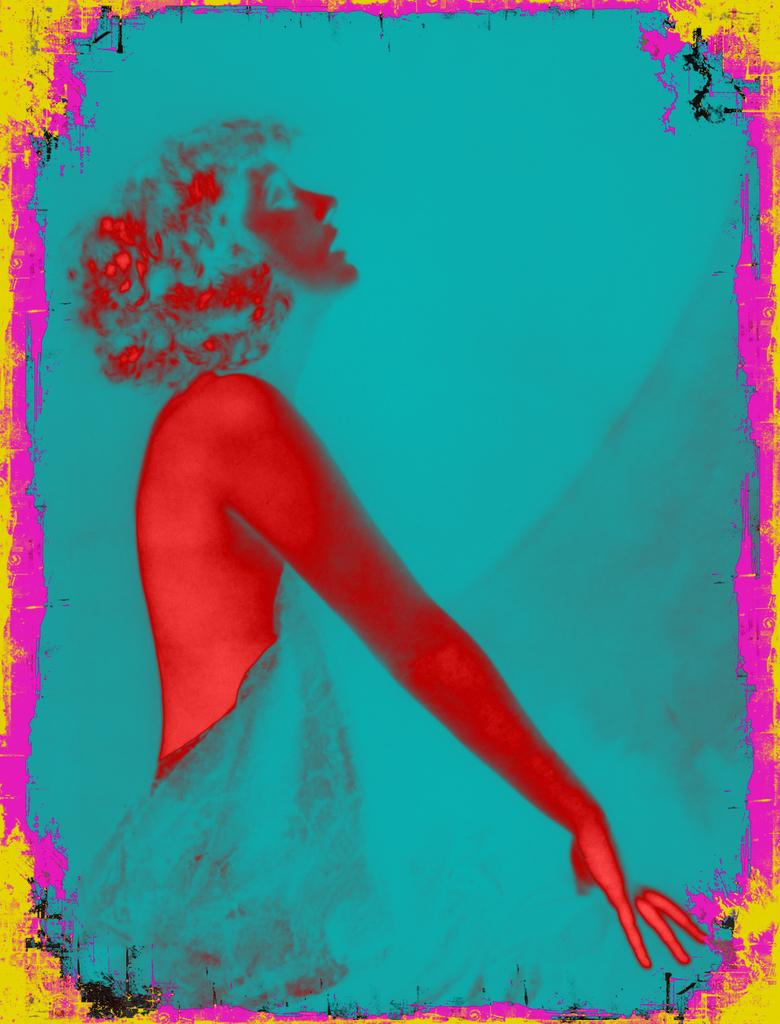What is the main subject of the image? There is a graphical image of a woman in the image. Can you describe the woman in the image? The provided facts do not include a description of the woman, so we cannot provide specific details about her appearance. What type of coat is the woman wearing on the island in the image? There is no coat, island, or any indication of the woman's location in the image. The image only features a graphical image of a woman, and no other details are provided. 